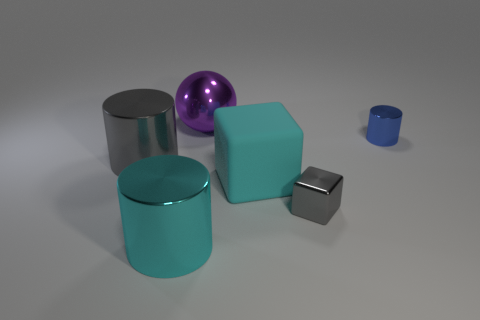Add 2 big gray cylinders. How many objects exist? 8 Subtract all balls. How many objects are left? 5 Subtract all purple metal balls. Subtract all tiny blue shiny things. How many objects are left? 4 Add 3 gray things. How many gray things are left? 5 Add 1 purple balls. How many purple balls exist? 2 Subtract 0 red cubes. How many objects are left? 6 